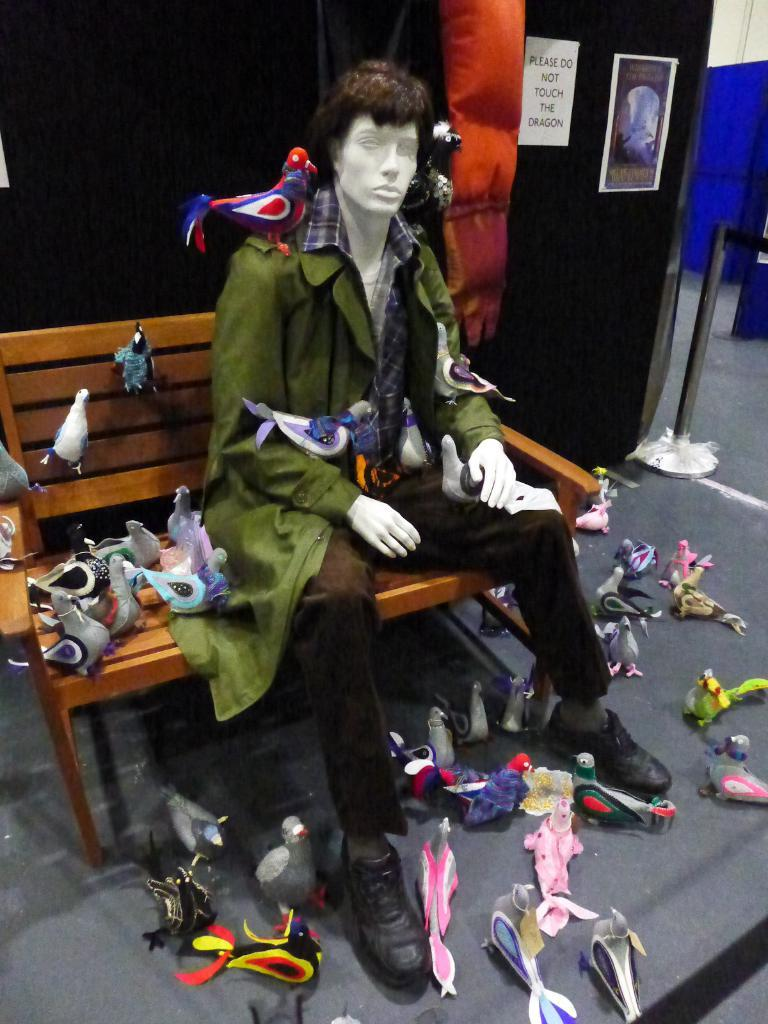What is on the bench in the image? There is a mannequin and toys on the bench in the image. What else can be seen on the floor in the background? In the background, there are toys on the floor. What type of structures are present in the background? The background includes walls and barrier poles. What type of visual communication is visible in the background? There is an advertisement visible in the background. What type of cushion is the mannequin sitting on in the image? There is no cushion present on the bench in the image; the mannequin is sitting directly on the bench. 